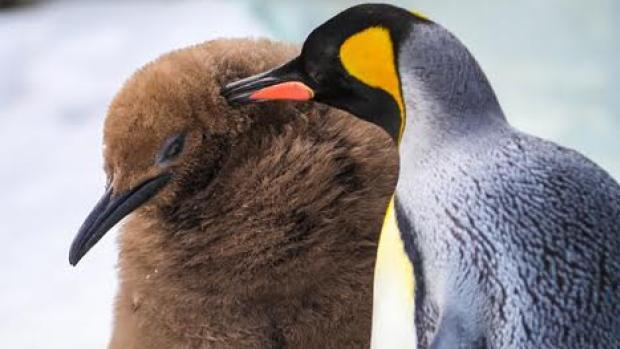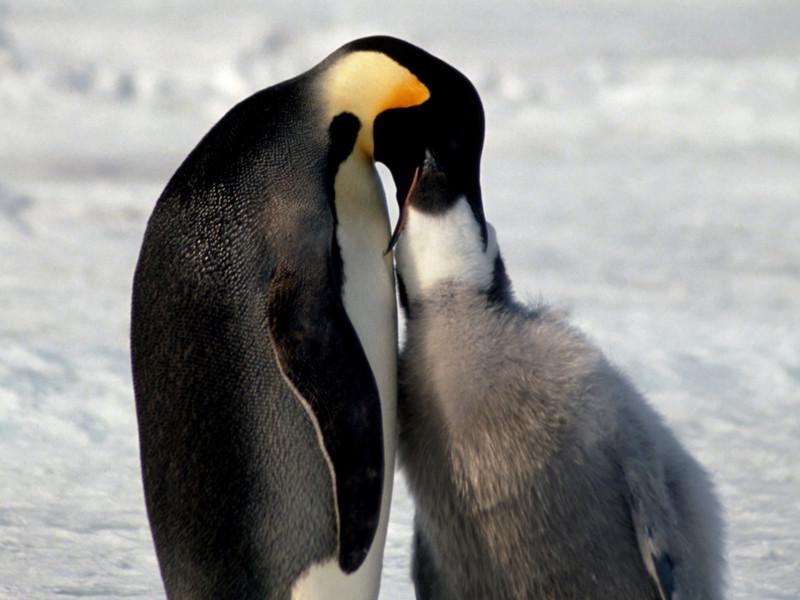The first image is the image on the left, the second image is the image on the right. For the images displayed, is the sentence "One penguin nuzzles another penguin in the back of the head." factually correct? Answer yes or no. Yes. The first image is the image on the left, the second image is the image on the right. Given the left and right images, does the statement "An image shows a penguin poking its mostly closed beak in the fuzzy feathers of another penguin." hold true? Answer yes or no. Yes. The first image is the image on the left, the second image is the image on the right. Evaluate the accuracy of this statement regarding the images: "One penguin is pushing a closed beak against the back of another penguin's head.". Is it true? Answer yes or no. Yes. 